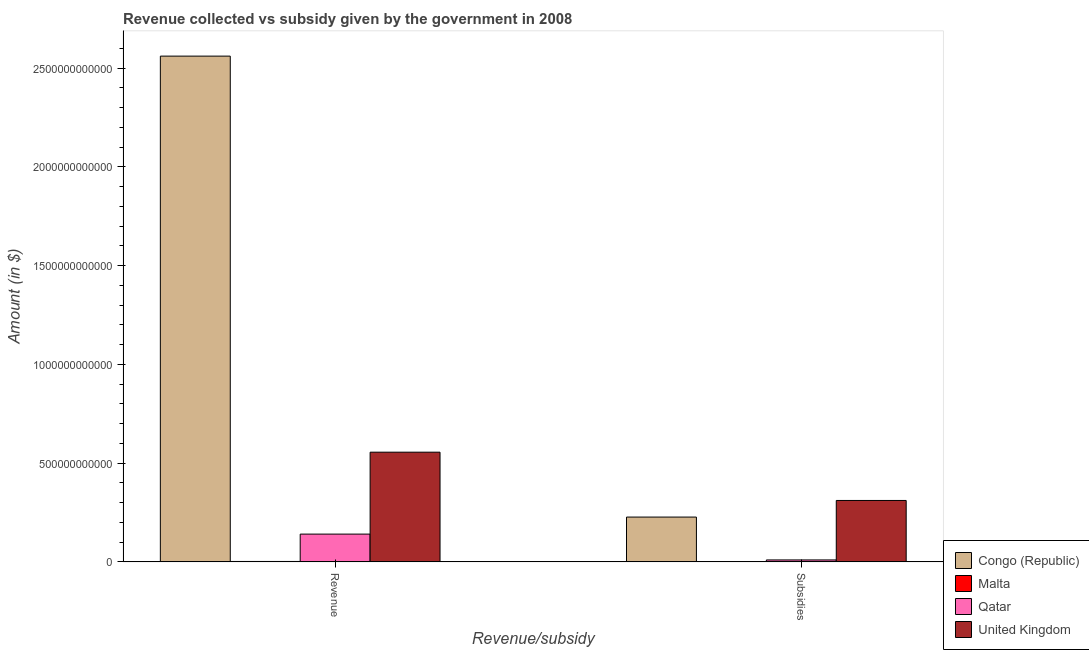How many different coloured bars are there?
Provide a succinct answer. 4. How many groups of bars are there?
Offer a very short reply. 2. What is the label of the 2nd group of bars from the left?
Make the answer very short. Subsidies. What is the amount of subsidies given in Congo (Republic)?
Your answer should be compact. 2.27e+11. Across all countries, what is the maximum amount of revenue collected?
Ensure brevity in your answer.  2.56e+12. Across all countries, what is the minimum amount of revenue collected?
Give a very brief answer. 2.24e+09. In which country was the amount of subsidies given minimum?
Give a very brief answer. Malta. What is the total amount of subsidies given in the graph?
Ensure brevity in your answer.  5.49e+11. What is the difference between the amount of revenue collected in Malta and that in Qatar?
Your answer should be compact. -1.39e+11. What is the difference between the amount of subsidies given in United Kingdom and the amount of revenue collected in Congo (Republic)?
Keep it short and to the point. -2.25e+12. What is the average amount of subsidies given per country?
Your answer should be very brief. 1.37e+11. What is the difference between the amount of revenue collected and amount of subsidies given in United Kingdom?
Offer a very short reply. 2.44e+11. In how many countries, is the amount of revenue collected greater than 1300000000000 $?
Provide a succinct answer. 1. What is the ratio of the amount of subsidies given in United Kingdom to that in Congo (Republic)?
Your answer should be very brief. 1.37. In how many countries, is the amount of subsidies given greater than the average amount of subsidies given taken over all countries?
Your answer should be very brief. 2. What does the 1st bar from the left in Subsidies represents?
Offer a terse response. Congo (Republic). Are all the bars in the graph horizontal?
Your response must be concise. No. What is the difference between two consecutive major ticks on the Y-axis?
Your answer should be compact. 5.00e+11. Are the values on the major ticks of Y-axis written in scientific E-notation?
Provide a short and direct response. No. Does the graph contain any zero values?
Provide a succinct answer. No. Does the graph contain grids?
Ensure brevity in your answer.  No. How many legend labels are there?
Offer a very short reply. 4. What is the title of the graph?
Your answer should be compact. Revenue collected vs subsidy given by the government in 2008. Does "Niger" appear as one of the legend labels in the graph?
Your answer should be compact. No. What is the label or title of the X-axis?
Give a very brief answer. Revenue/subsidy. What is the label or title of the Y-axis?
Your response must be concise. Amount (in $). What is the Amount (in $) of Congo (Republic) in Revenue?
Offer a very short reply. 2.56e+12. What is the Amount (in $) of Malta in Revenue?
Provide a succinct answer. 2.24e+09. What is the Amount (in $) of Qatar in Revenue?
Your answer should be very brief. 1.41e+11. What is the Amount (in $) of United Kingdom in Revenue?
Provide a succinct answer. 5.56e+11. What is the Amount (in $) of Congo (Republic) in Subsidies?
Ensure brevity in your answer.  2.27e+11. What is the Amount (in $) in Malta in Subsidies?
Offer a terse response. 9.47e+08. What is the Amount (in $) of Qatar in Subsidies?
Your answer should be compact. 9.95e+09. What is the Amount (in $) of United Kingdom in Subsidies?
Your response must be concise. 3.11e+11. Across all Revenue/subsidy, what is the maximum Amount (in $) of Congo (Republic)?
Offer a terse response. 2.56e+12. Across all Revenue/subsidy, what is the maximum Amount (in $) of Malta?
Ensure brevity in your answer.  2.24e+09. Across all Revenue/subsidy, what is the maximum Amount (in $) in Qatar?
Ensure brevity in your answer.  1.41e+11. Across all Revenue/subsidy, what is the maximum Amount (in $) in United Kingdom?
Make the answer very short. 5.56e+11. Across all Revenue/subsidy, what is the minimum Amount (in $) in Congo (Republic)?
Your answer should be compact. 2.27e+11. Across all Revenue/subsidy, what is the minimum Amount (in $) of Malta?
Provide a short and direct response. 9.47e+08. Across all Revenue/subsidy, what is the minimum Amount (in $) in Qatar?
Your answer should be very brief. 9.95e+09. Across all Revenue/subsidy, what is the minimum Amount (in $) of United Kingdom?
Offer a very short reply. 3.11e+11. What is the total Amount (in $) in Congo (Republic) in the graph?
Ensure brevity in your answer.  2.79e+12. What is the total Amount (in $) in Malta in the graph?
Ensure brevity in your answer.  3.19e+09. What is the total Amount (in $) of Qatar in the graph?
Your answer should be compact. 1.51e+11. What is the total Amount (in $) of United Kingdom in the graph?
Give a very brief answer. 8.67e+11. What is the difference between the Amount (in $) in Congo (Republic) in Revenue and that in Subsidies?
Give a very brief answer. 2.33e+12. What is the difference between the Amount (in $) in Malta in Revenue and that in Subsidies?
Your answer should be very brief. 1.30e+09. What is the difference between the Amount (in $) in Qatar in Revenue and that in Subsidies?
Make the answer very short. 1.31e+11. What is the difference between the Amount (in $) of United Kingdom in Revenue and that in Subsidies?
Keep it short and to the point. 2.44e+11. What is the difference between the Amount (in $) in Congo (Republic) in Revenue and the Amount (in $) in Malta in Subsidies?
Ensure brevity in your answer.  2.56e+12. What is the difference between the Amount (in $) of Congo (Republic) in Revenue and the Amount (in $) of Qatar in Subsidies?
Your answer should be compact. 2.55e+12. What is the difference between the Amount (in $) in Congo (Republic) in Revenue and the Amount (in $) in United Kingdom in Subsidies?
Make the answer very short. 2.25e+12. What is the difference between the Amount (in $) in Malta in Revenue and the Amount (in $) in Qatar in Subsidies?
Make the answer very short. -7.71e+09. What is the difference between the Amount (in $) of Malta in Revenue and the Amount (in $) of United Kingdom in Subsidies?
Make the answer very short. -3.09e+11. What is the difference between the Amount (in $) in Qatar in Revenue and the Amount (in $) in United Kingdom in Subsidies?
Give a very brief answer. -1.70e+11. What is the average Amount (in $) in Congo (Republic) per Revenue/subsidy?
Offer a terse response. 1.39e+12. What is the average Amount (in $) of Malta per Revenue/subsidy?
Offer a terse response. 1.59e+09. What is the average Amount (in $) of Qatar per Revenue/subsidy?
Your response must be concise. 7.54e+1. What is the average Amount (in $) in United Kingdom per Revenue/subsidy?
Make the answer very short. 4.33e+11. What is the difference between the Amount (in $) of Congo (Republic) and Amount (in $) of Malta in Revenue?
Your answer should be compact. 2.56e+12. What is the difference between the Amount (in $) of Congo (Republic) and Amount (in $) of Qatar in Revenue?
Ensure brevity in your answer.  2.42e+12. What is the difference between the Amount (in $) of Congo (Republic) and Amount (in $) of United Kingdom in Revenue?
Give a very brief answer. 2.01e+12. What is the difference between the Amount (in $) in Malta and Amount (in $) in Qatar in Revenue?
Your response must be concise. -1.39e+11. What is the difference between the Amount (in $) in Malta and Amount (in $) in United Kingdom in Revenue?
Provide a succinct answer. -5.53e+11. What is the difference between the Amount (in $) of Qatar and Amount (in $) of United Kingdom in Revenue?
Give a very brief answer. -4.15e+11. What is the difference between the Amount (in $) in Congo (Republic) and Amount (in $) in Malta in Subsidies?
Make the answer very short. 2.26e+11. What is the difference between the Amount (in $) in Congo (Republic) and Amount (in $) in Qatar in Subsidies?
Your answer should be very brief. 2.17e+11. What is the difference between the Amount (in $) in Congo (Republic) and Amount (in $) in United Kingdom in Subsidies?
Your response must be concise. -8.42e+1. What is the difference between the Amount (in $) in Malta and Amount (in $) in Qatar in Subsidies?
Ensure brevity in your answer.  -9.01e+09. What is the difference between the Amount (in $) in Malta and Amount (in $) in United Kingdom in Subsidies?
Provide a succinct answer. -3.10e+11. What is the difference between the Amount (in $) in Qatar and Amount (in $) in United Kingdom in Subsidies?
Give a very brief answer. -3.01e+11. What is the ratio of the Amount (in $) in Congo (Republic) in Revenue to that in Subsidies?
Keep it short and to the point. 11.28. What is the ratio of the Amount (in $) of Malta in Revenue to that in Subsidies?
Your response must be concise. 2.37. What is the ratio of the Amount (in $) in Qatar in Revenue to that in Subsidies?
Ensure brevity in your answer.  14.14. What is the ratio of the Amount (in $) of United Kingdom in Revenue to that in Subsidies?
Provide a succinct answer. 1.79. What is the difference between the highest and the second highest Amount (in $) of Congo (Republic)?
Offer a very short reply. 2.33e+12. What is the difference between the highest and the second highest Amount (in $) in Malta?
Keep it short and to the point. 1.30e+09. What is the difference between the highest and the second highest Amount (in $) in Qatar?
Offer a very short reply. 1.31e+11. What is the difference between the highest and the second highest Amount (in $) in United Kingdom?
Offer a very short reply. 2.44e+11. What is the difference between the highest and the lowest Amount (in $) of Congo (Republic)?
Offer a terse response. 2.33e+12. What is the difference between the highest and the lowest Amount (in $) of Malta?
Your answer should be very brief. 1.30e+09. What is the difference between the highest and the lowest Amount (in $) in Qatar?
Your answer should be compact. 1.31e+11. What is the difference between the highest and the lowest Amount (in $) in United Kingdom?
Offer a very short reply. 2.44e+11. 